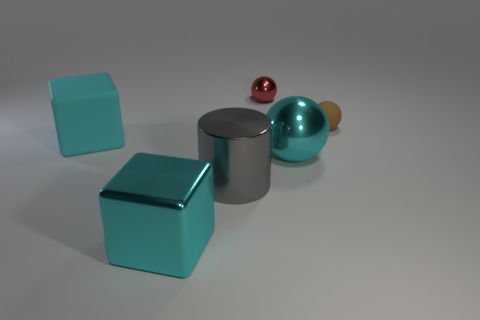How many shiny spheres are the same size as the gray metal thing?
Provide a succinct answer. 1. The sphere that is both behind the large shiny sphere and in front of the red object is what color?
Provide a short and direct response. Brown. What number of things are either big cyan spheres or rubber things?
Your answer should be very brief. 3. How many large objects are either gray objects or red objects?
Provide a short and direct response. 1. Is there any other thing that is the same color as the large metallic cylinder?
Your answer should be compact. No. What size is the shiny object that is both behind the big gray thing and in front of the red metallic thing?
Your answer should be very brief. Large. Is the color of the rubber object that is to the left of the matte sphere the same as the metallic thing on the right side of the red thing?
Keep it short and to the point. Yes. What number of other objects are the same material as the big cylinder?
Your answer should be very brief. 3. What shape is the shiny thing that is both behind the gray cylinder and in front of the small brown rubber sphere?
Offer a terse response. Sphere. Is the color of the metal cube the same as the block that is behind the gray shiny thing?
Make the answer very short. Yes. 